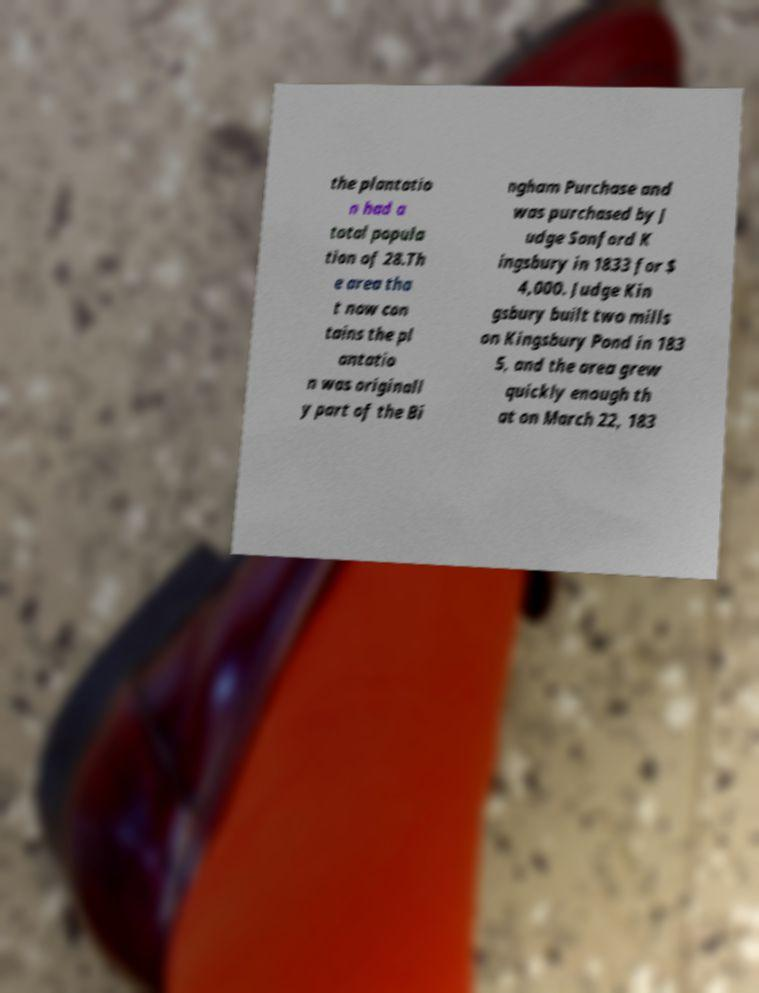There's text embedded in this image that I need extracted. Can you transcribe it verbatim? the plantatio n had a total popula tion of 28.Th e area tha t now con tains the pl antatio n was originall y part of the Bi ngham Purchase and was purchased by J udge Sanford K ingsbury in 1833 for $ 4,000. Judge Kin gsbury built two mills on Kingsbury Pond in 183 5, and the area grew quickly enough th at on March 22, 183 